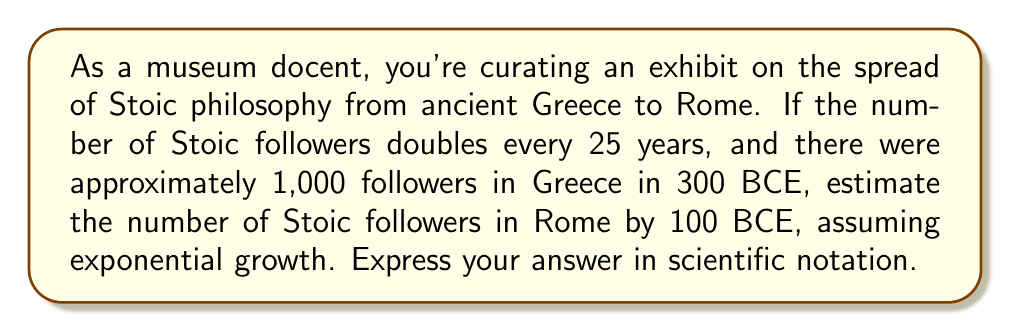What is the answer to this math problem? To solve this problem, we need to use the exponential growth formula and follow these steps:

1. Identify the key components:
   - Initial number of followers: $N_0 = 1,000$
   - Growth rate: doubles every 25 years, so $r = 2^{\frac{1}{25}} - 1$ per year
   - Time period: from 300 BCE to 100 BCE, so $t = 200$ years

2. Calculate the growth rate per year:
   $r = 2^{\frac{1}{25}} - 1 \approx 0.0281$ or about 2.81% per year

3. Use the exponential growth formula:
   $N(t) = N_0 \cdot (1 + r)^t$

4. Substitute the values:
   $N(200) = 1,000 \cdot (1 + 0.0281)^{200}$

5. Calculate:
   $N(200) = 1,000 \cdot (1.0281)^{200}$
   $N(200) = 1,000 \cdot 272.49$
   $N(200) = 272,490$

6. Express in scientific notation:
   $N(200) = 2.72490 \times 10^5$

Therefore, by 100 BCE, there would be approximately $2.72 \times 10^5$ Stoic followers in Rome, assuming exponential growth.
Answer: $2.72 \times 10^5$ Stoic followers 